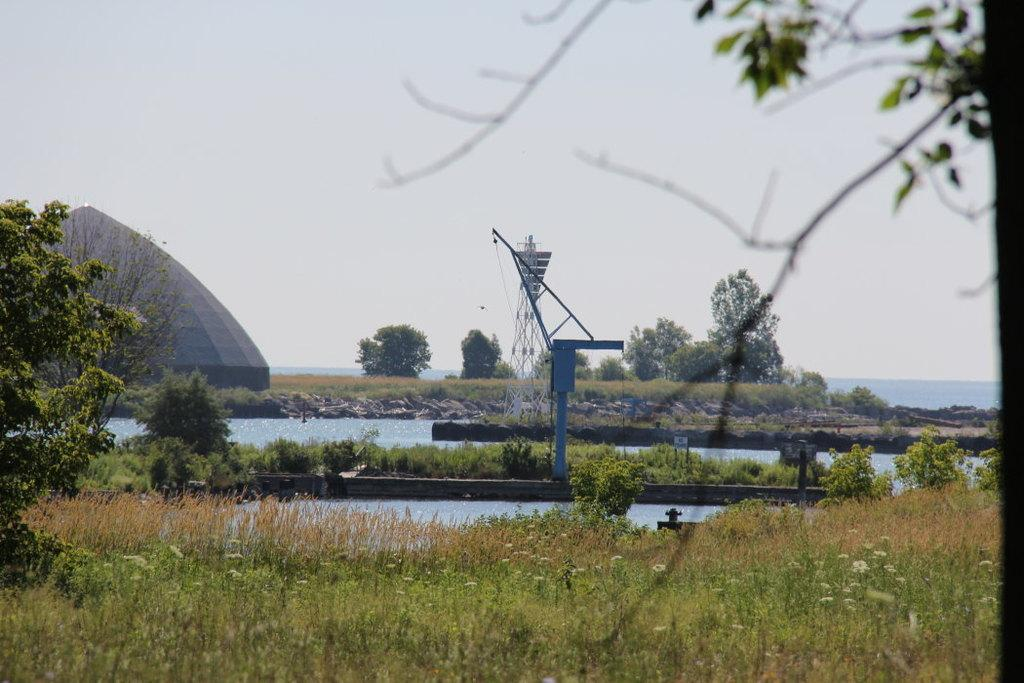What type of vegetation covers the land in the front of the image? The land in the front of the image is covered with grass. What body of water can be seen in the image? There is a lake in the image. What structure is located on the left side of the image? There appears to be a tomb on the left side of the image. What is visible above the land and lake in the image? A: The sky is visible in the image. Where is the vase placed in the image? There is no vase present in the image. What type of canvas is used to depict the scene in the image? The image is not a painting or drawing; it is a photograph or a real-life scene. 